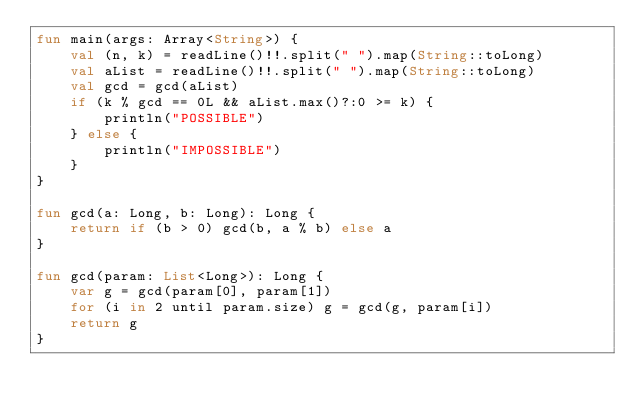<code> <loc_0><loc_0><loc_500><loc_500><_Kotlin_>fun main(args: Array<String>) {
    val (n, k) = readLine()!!.split(" ").map(String::toLong)
    val aList = readLine()!!.split(" ").map(String::toLong)
    val gcd = gcd(aList)
    if (k % gcd == 0L && aList.max()?:0 >= k) {
        println("POSSIBLE")
    } else {
        println("IMPOSSIBLE")
    }
}

fun gcd(a: Long, b: Long): Long {
    return if (b > 0) gcd(b, a % b) else a
}

fun gcd(param: List<Long>): Long {
    var g = gcd(param[0], param[1])
    for (i in 2 until param.size) g = gcd(g, param[i])
    return g
}</code> 